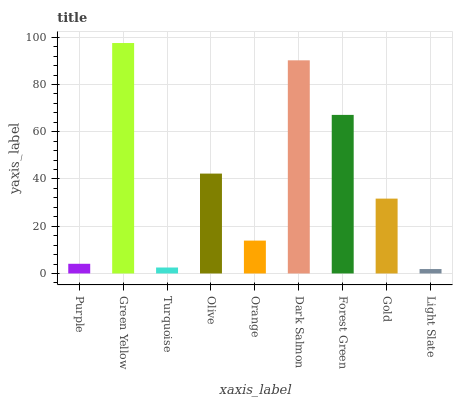Is Light Slate the minimum?
Answer yes or no. Yes. Is Green Yellow the maximum?
Answer yes or no. Yes. Is Turquoise the minimum?
Answer yes or no. No. Is Turquoise the maximum?
Answer yes or no. No. Is Green Yellow greater than Turquoise?
Answer yes or no. Yes. Is Turquoise less than Green Yellow?
Answer yes or no. Yes. Is Turquoise greater than Green Yellow?
Answer yes or no. No. Is Green Yellow less than Turquoise?
Answer yes or no. No. Is Gold the high median?
Answer yes or no. Yes. Is Gold the low median?
Answer yes or no. Yes. Is Light Slate the high median?
Answer yes or no. No. Is Purple the low median?
Answer yes or no. No. 